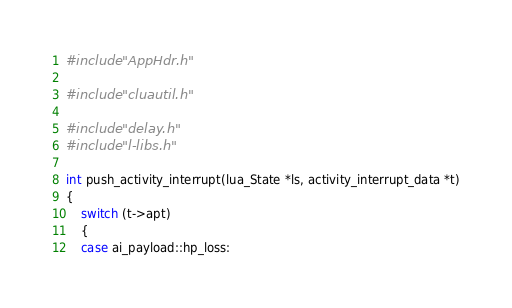<code> <loc_0><loc_0><loc_500><loc_500><_C++_>#include "AppHdr.h"

#include "cluautil.h"

#include "delay.h"
#include "l-libs.h"

int push_activity_interrupt(lua_State *ls, activity_interrupt_data *t)
{
    switch (t->apt)
    {
    case ai_payload::hp_loss:</code> 